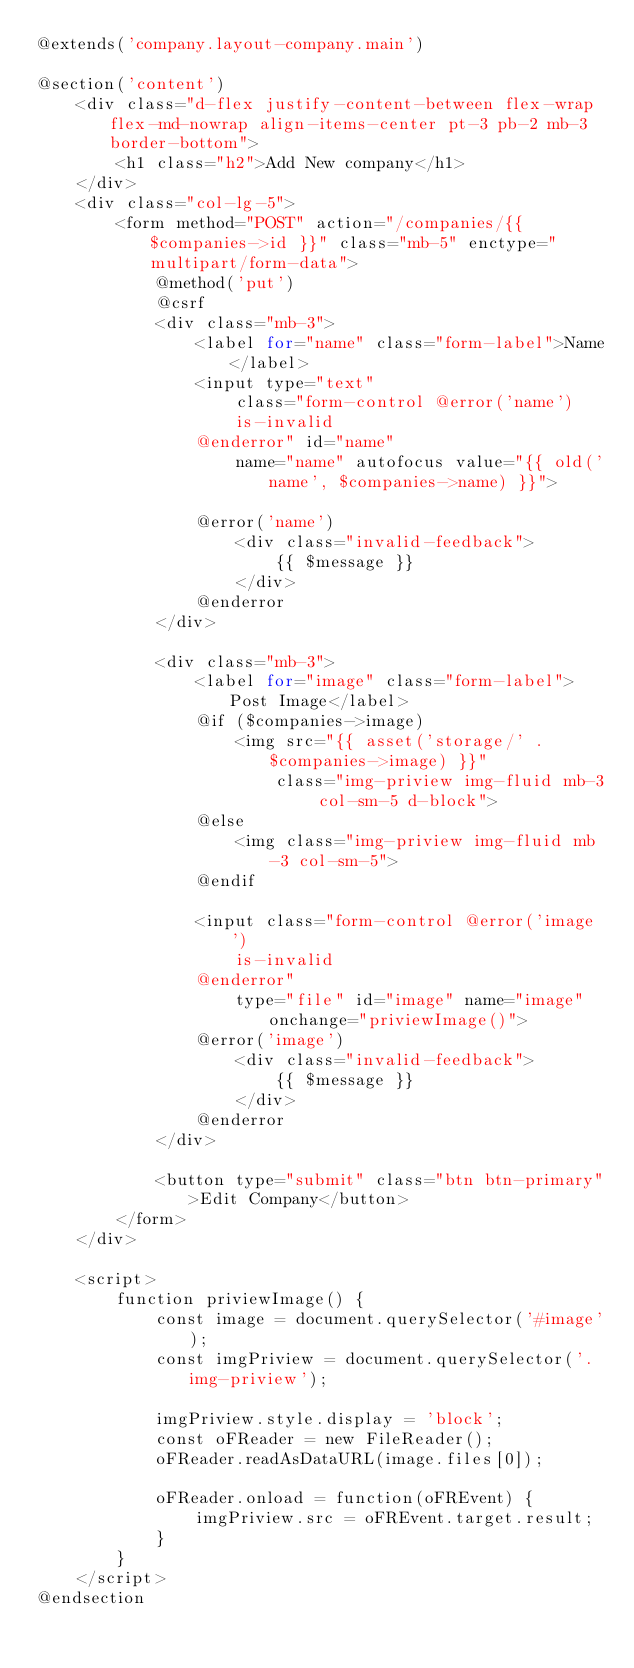Convert code to text. <code><loc_0><loc_0><loc_500><loc_500><_PHP_>@extends('company.layout-company.main')

@section('content')
    <div class="d-flex justify-content-between flex-wrap flex-md-nowrap align-items-center pt-3 pb-2 mb-3 border-bottom">
        <h1 class="h2">Add New company</h1>
    </div>
    <div class="col-lg-5">
        <form method="POST" action="/companies/{{ $companies->id }}" class="mb-5" enctype="multipart/form-data">
            @method('put')
            @csrf
            <div class="mb-3">
                <label for="name" class="form-label">Name</label>
                <input type="text"
                    class="form-control @error('name')
                    is-invalid
                @enderror" id="name"
                    name="name" autofocus value="{{ old('name', $companies->name) }}">

                @error('name')
                    <div class="invalid-feedback">
                        {{ $message }}
                    </div>
                @enderror
            </div>

            <div class="mb-3">
                <label for="image" class="form-label">Post Image</label>
                @if ($companies->image)
                    <img src="{{ asset('storage/' . $companies->image) }}"
                        class="img-priview img-fluid mb-3 col-sm-5 d-block">
                @else
                    <img class="img-priview img-fluid mb-3 col-sm-5">
                @endif

                <input class="form-control @error('image')
                    is-invalid
                @enderror"
                    type="file" id="image" name="image" onchange="priviewImage()">
                @error('image')
                    <div class="invalid-feedback">
                        {{ $message }}
                    </div>
                @enderror
            </div>

            <button type="submit" class="btn btn-primary">Edit Company</button>
        </form>
    </div>

    <script>
        function priviewImage() {
            const image = document.querySelector('#image');
            const imgPriview = document.querySelector('.img-priview');

            imgPriview.style.display = 'block';
            const oFReader = new FileReader();
            oFReader.readAsDataURL(image.files[0]);

            oFReader.onload = function(oFREvent) {
                imgPriview.src = oFREvent.target.result;
            }
        }
    </script>
@endsection
</code> 